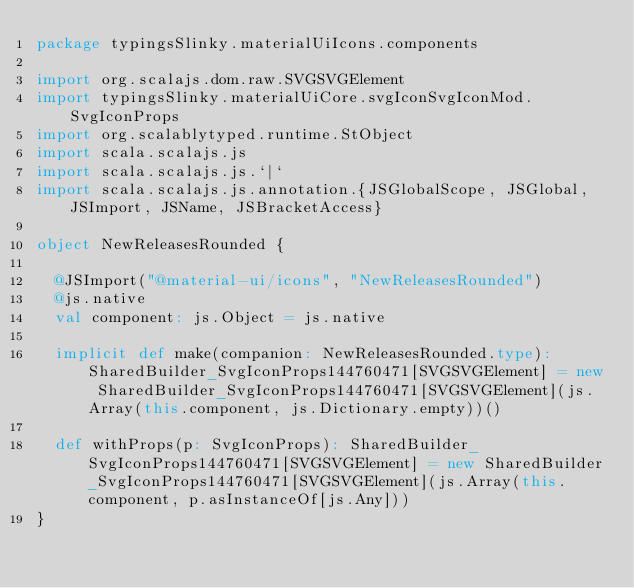Convert code to text. <code><loc_0><loc_0><loc_500><loc_500><_Scala_>package typingsSlinky.materialUiIcons.components

import org.scalajs.dom.raw.SVGSVGElement
import typingsSlinky.materialUiCore.svgIconSvgIconMod.SvgIconProps
import org.scalablytyped.runtime.StObject
import scala.scalajs.js
import scala.scalajs.js.`|`
import scala.scalajs.js.annotation.{JSGlobalScope, JSGlobal, JSImport, JSName, JSBracketAccess}

object NewReleasesRounded {
  
  @JSImport("@material-ui/icons", "NewReleasesRounded")
  @js.native
  val component: js.Object = js.native
  
  implicit def make(companion: NewReleasesRounded.type): SharedBuilder_SvgIconProps144760471[SVGSVGElement] = new SharedBuilder_SvgIconProps144760471[SVGSVGElement](js.Array(this.component, js.Dictionary.empty))()
  
  def withProps(p: SvgIconProps): SharedBuilder_SvgIconProps144760471[SVGSVGElement] = new SharedBuilder_SvgIconProps144760471[SVGSVGElement](js.Array(this.component, p.asInstanceOf[js.Any]))
}
</code> 